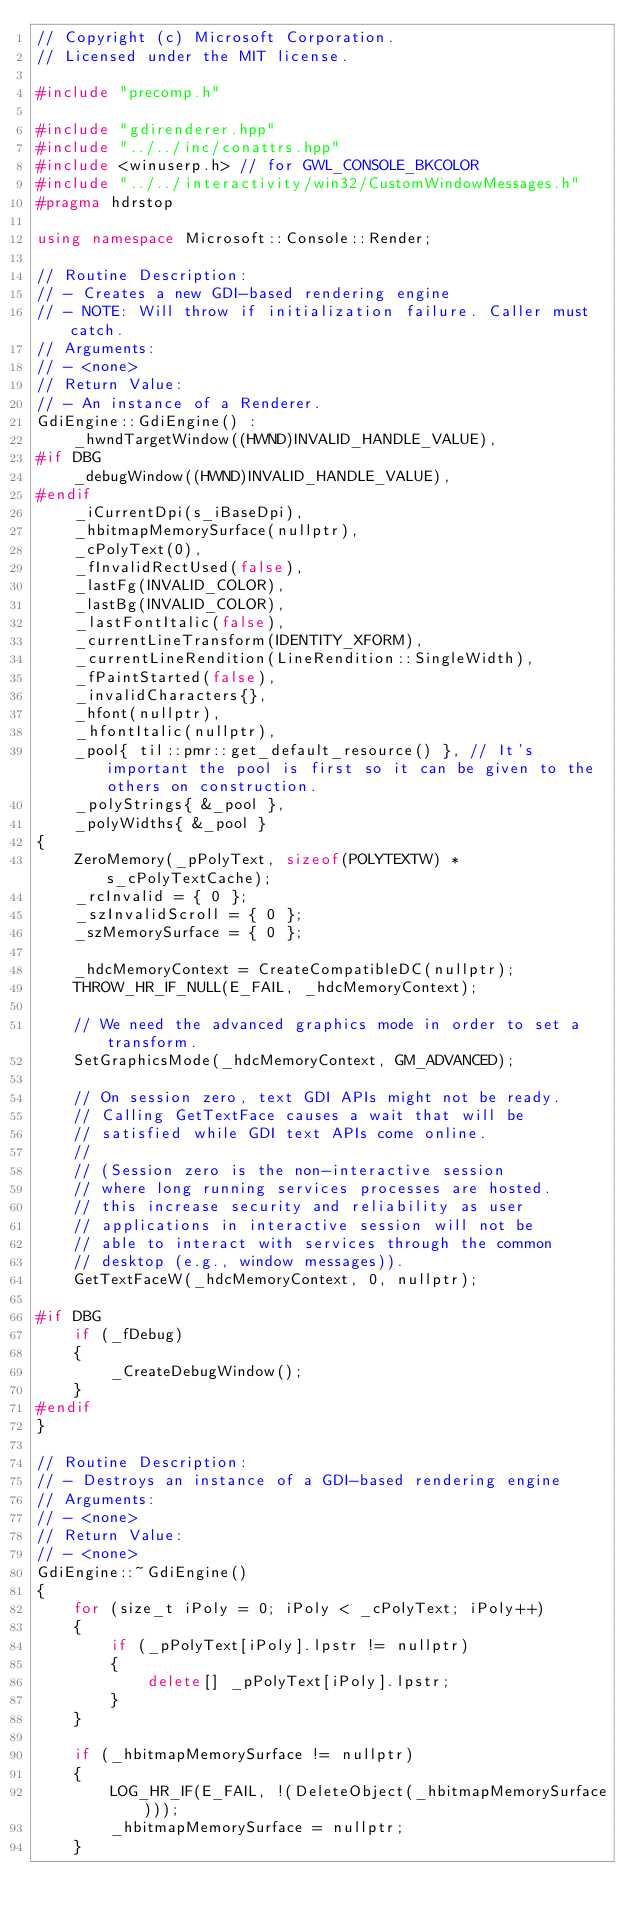<code> <loc_0><loc_0><loc_500><loc_500><_C++_>// Copyright (c) Microsoft Corporation.
// Licensed under the MIT license.

#include "precomp.h"

#include "gdirenderer.hpp"
#include "../../inc/conattrs.hpp"
#include <winuserp.h> // for GWL_CONSOLE_BKCOLOR
#include "../../interactivity/win32/CustomWindowMessages.h"
#pragma hdrstop

using namespace Microsoft::Console::Render;

// Routine Description:
// - Creates a new GDI-based rendering engine
// - NOTE: Will throw if initialization failure. Caller must catch.
// Arguments:
// - <none>
// Return Value:
// - An instance of a Renderer.
GdiEngine::GdiEngine() :
    _hwndTargetWindow((HWND)INVALID_HANDLE_VALUE),
#if DBG
    _debugWindow((HWND)INVALID_HANDLE_VALUE),
#endif
    _iCurrentDpi(s_iBaseDpi),
    _hbitmapMemorySurface(nullptr),
    _cPolyText(0),
    _fInvalidRectUsed(false),
    _lastFg(INVALID_COLOR),
    _lastBg(INVALID_COLOR),
    _lastFontItalic(false),
    _currentLineTransform(IDENTITY_XFORM),
    _currentLineRendition(LineRendition::SingleWidth),
    _fPaintStarted(false),
    _invalidCharacters{},
    _hfont(nullptr),
    _hfontItalic(nullptr),
    _pool{ til::pmr::get_default_resource() }, // It's important the pool is first so it can be given to the others on construction.
    _polyStrings{ &_pool },
    _polyWidths{ &_pool }
{
    ZeroMemory(_pPolyText, sizeof(POLYTEXTW) * s_cPolyTextCache);
    _rcInvalid = { 0 };
    _szInvalidScroll = { 0 };
    _szMemorySurface = { 0 };

    _hdcMemoryContext = CreateCompatibleDC(nullptr);
    THROW_HR_IF_NULL(E_FAIL, _hdcMemoryContext);

    // We need the advanced graphics mode in order to set a transform.
    SetGraphicsMode(_hdcMemoryContext, GM_ADVANCED);

    // On session zero, text GDI APIs might not be ready.
    // Calling GetTextFace causes a wait that will be
    // satisfied while GDI text APIs come online.
    //
    // (Session zero is the non-interactive session
    // where long running services processes are hosted.
    // this increase security and reliability as user
    // applications in interactive session will not be
    // able to interact with services through the common
    // desktop (e.g., window messages)).
    GetTextFaceW(_hdcMemoryContext, 0, nullptr);

#if DBG
    if (_fDebug)
    {
        _CreateDebugWindow();
    }
#endif
}

// Routine Description:
// - Destroys an instance of a GDI-based rendering engine
// Arguments:
// - <none>
// Return Value:
// - <none>
GdiEngine::~GdiEngine()
{
    for (size_t iPoly = 0; iPoly < _cPolyText; iPoly++)
    {
        if (_pPolyText[iPoly].lpstr != nullptr)
        {
            delete[] _pPolyText[iPoly].lpstr;
        }
    }

    if (_hbitmapMemorySurface != nullptr)
    {
        LOG_HR_IF(E_FAIL, !(DeleteObject(_hbitmapMemorySurface)));
        _hbitmapMemorySurface = nullptr;
    }
</code> 